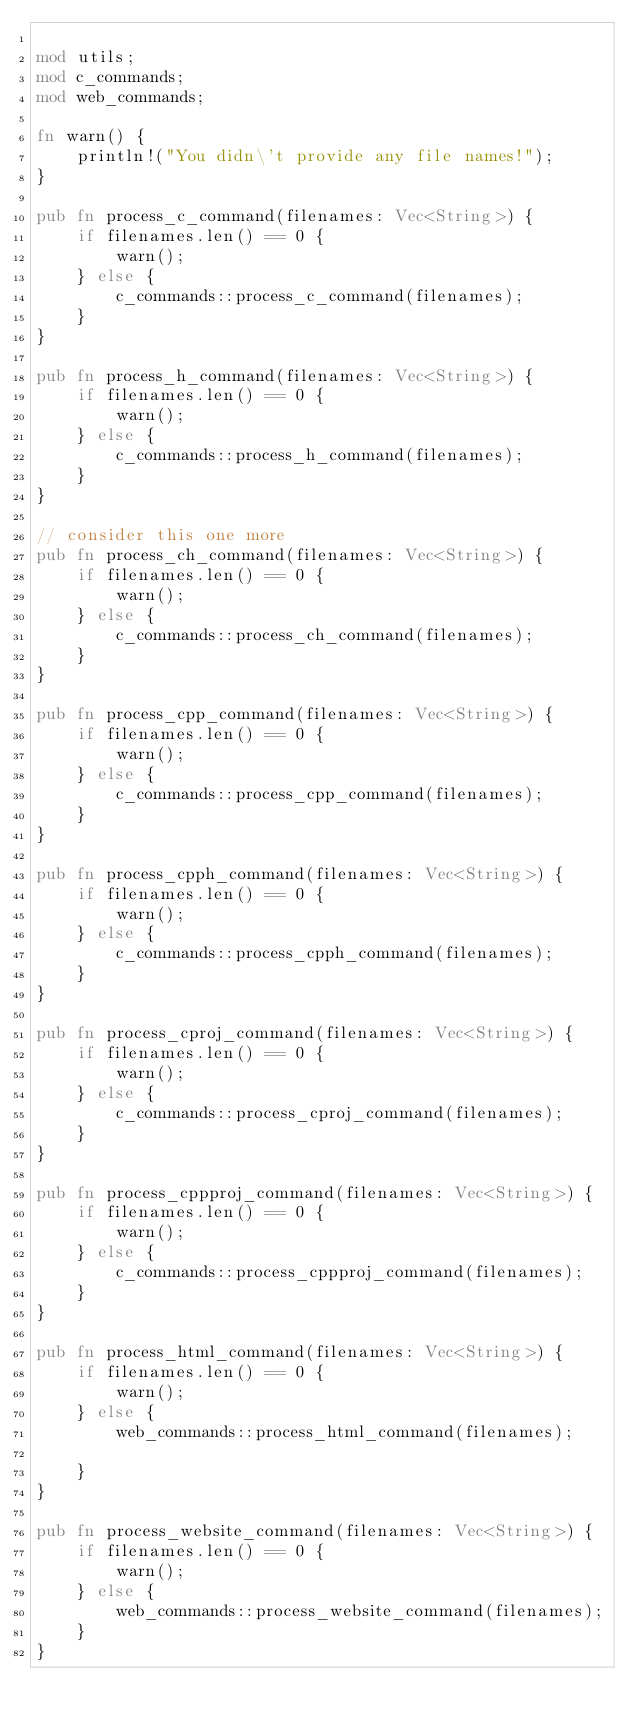<code> <loc_0><loc_0><loc_500><loc_500><_Rust_>
mod utils;
mod c_commands;
mod web_commands;

fn warn() {
    println!("You didn\'t provide any file names!");
}

pub fn process_c_command(filenames: Vec<String>) {
    if filenames.len() == 0 {
        warn();
    } else {
        c_commands::process_c_command(filenames);
    }
}

pub fn process_h_command(filenames: Vec<String>) {
    if filenames.len() == 0 {
        warn();
    } else {
        c_commands::process_h_command(filenames);
    }
}

// consider this one more
pub fn process_ch_command(filenames: Vec<String>) {
    if filenames.len() == 0 {
        warn();
    } else {
        c_commands::process_ch_command(filenames);
    }
}

pub fn process_cpp_command(filenames: Vec<String>) {
    if filenames.len() == 0 {
        warn();
    } else {
        c_commands::process_cpp_command(filenames);
    }
}

pub fn process_cpph_command(filenames: Vec<String>) {
    if filenames.len() == 0 {
        warn();
    } else {
        c_commands::process_cpph_command(filenames);
    }
}

pub fn process_cproj_command(filenames: Vec<String>) {
    if filenames.len() == 0 {
        warn();
    } else {
        c_commands::process_cproj_command(filenames);
    }
}

pub fn process_cppproj_command(filenames: Vec<String>) {
    if filenames.len() == 0 {
        warn();
    } else {
        c_commands::process_cppproj_command(filenames);
    }
}

pub fn process_html_command(filenames: Vec<String>) {
    if filenames.len() == 0 {
        warn();
    } else {
        web_commands::process_html_command(filenames);

    }
}

pub fn process_website_command(filenames: Vec<String>) {
    if filenames.len() == 0 {
        warn();
    } else {
        web_commands::process_website_command(filenames);
    }
}</code> 